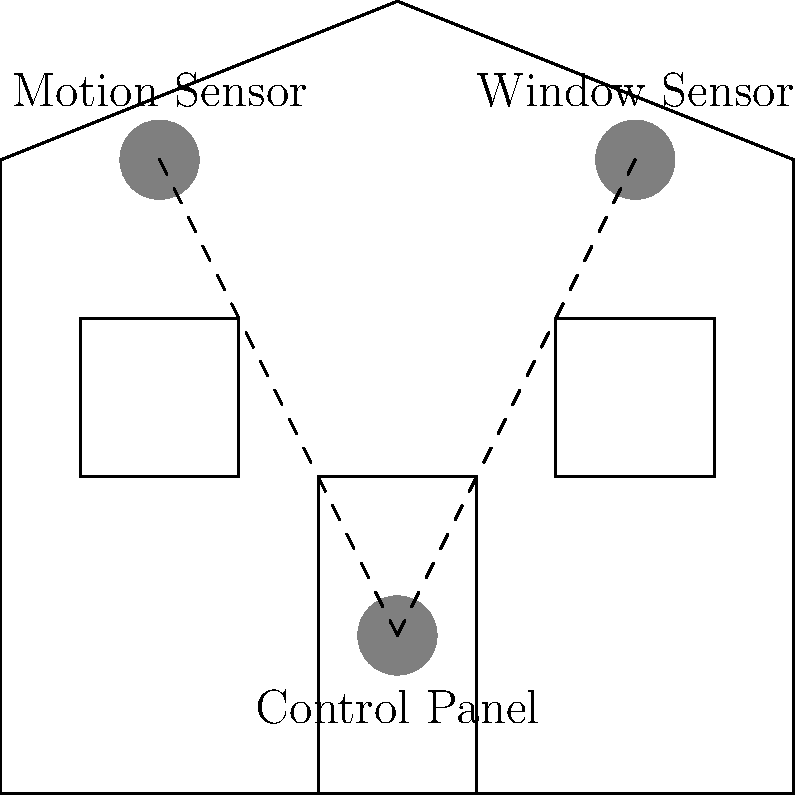In the basic home alarm system wiring diagram shown above, what does the dashed line connecting the sensors to the control panel represent? Let's break down the diagram step-by-step:

1. The diagram shows a simple house outline with a door and two windows.

2. There are three circular components in the diagram:
   - One near the top left, labeled "Motion Sensor"
   - One near the top right, labeled "Window Sensor"
   - One near the bottom center, labeled "Control Panel"

3. Dashed lines connect both the Motion Sensor and the Window Sensor to the Control Panel.

4. In alarm system diagrams, dashed lines typically represent wiring or connections between components.

5. The purpose of these connections is to allow the sensors to communicate with the control panel, sending signals when they detect motion or a window opening.

6. Wiring is essential in a traditional, hardwired alarm system to transmit information from the sensors to the central control panel.

Therefore, the dashed lines in this diagram represent the wiring that connects the sensors to the control panel, allowing the alarm system to function as a cohesive unit.
Answer: Wiring 